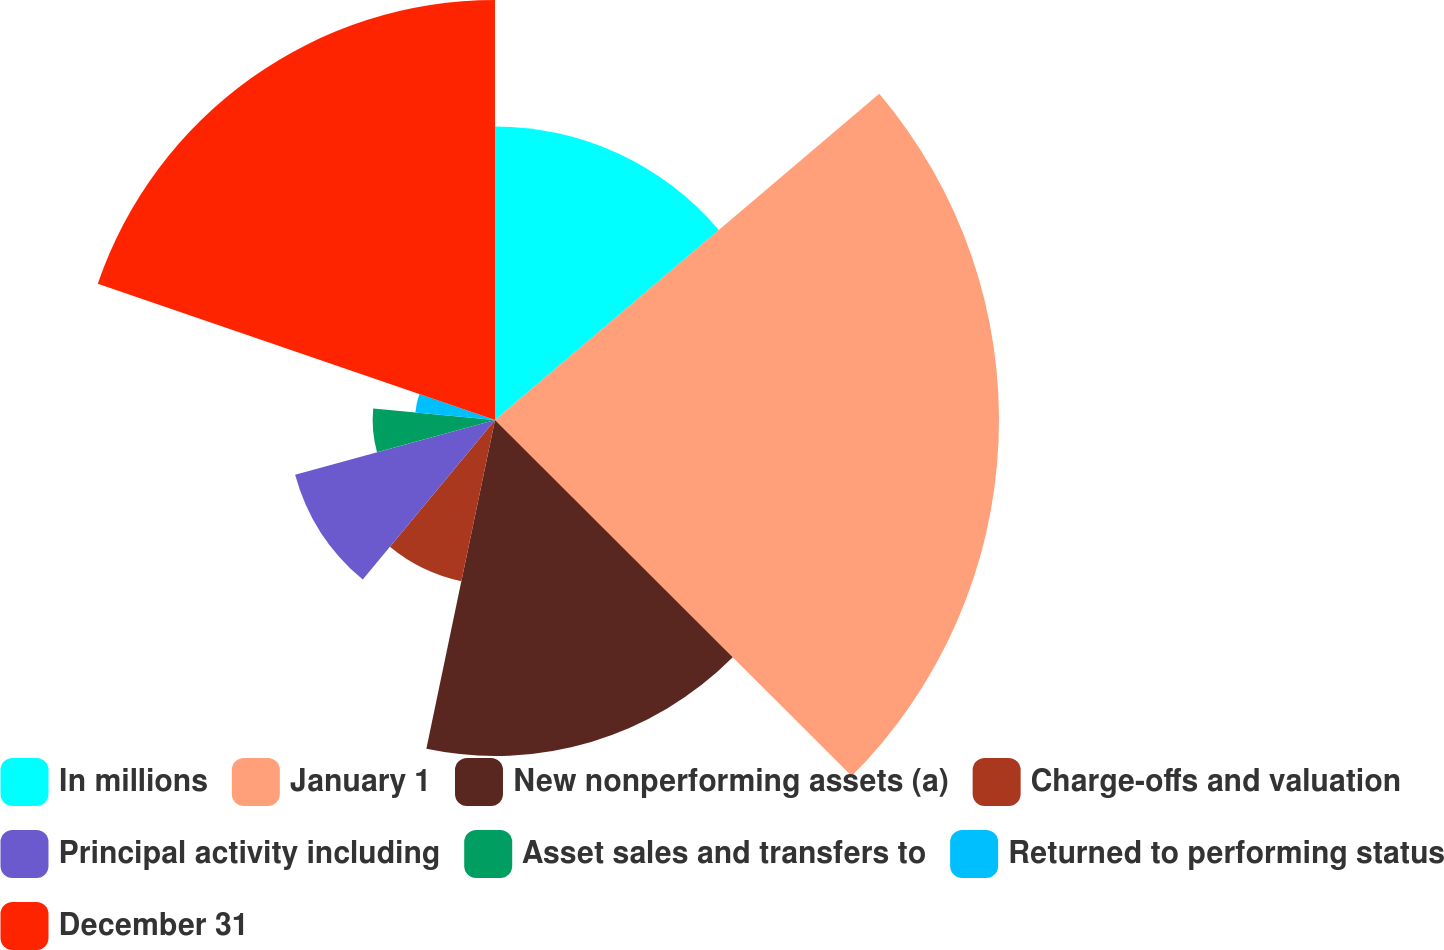Convert chart to OTSL. <chart><loc_0><loc_0><loc_500><loc_500><pie_chart><fcel>In millions<fcel>January 1<fcel>New nonperforming assets (a)<fcel>Charge-offs and valuation<fcel>Principal activity including<fcel>Asset sales and transfers to<fcel>Returned to performing status<fcel>December 31<nl><fcel>13.8%<fcel>23.69%<fcel>15.79%<fcel>7.74%<fcel>9.74%<fcel>5.75%<fcel>3.76%<fcel>19.74%<nl></chart> 